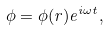Convert formula to latex. <formula><loc_0><loc_0><loc_500><loc_500>\phi = \phi ( r ) e ^ { i \omega t } ,</formula> 